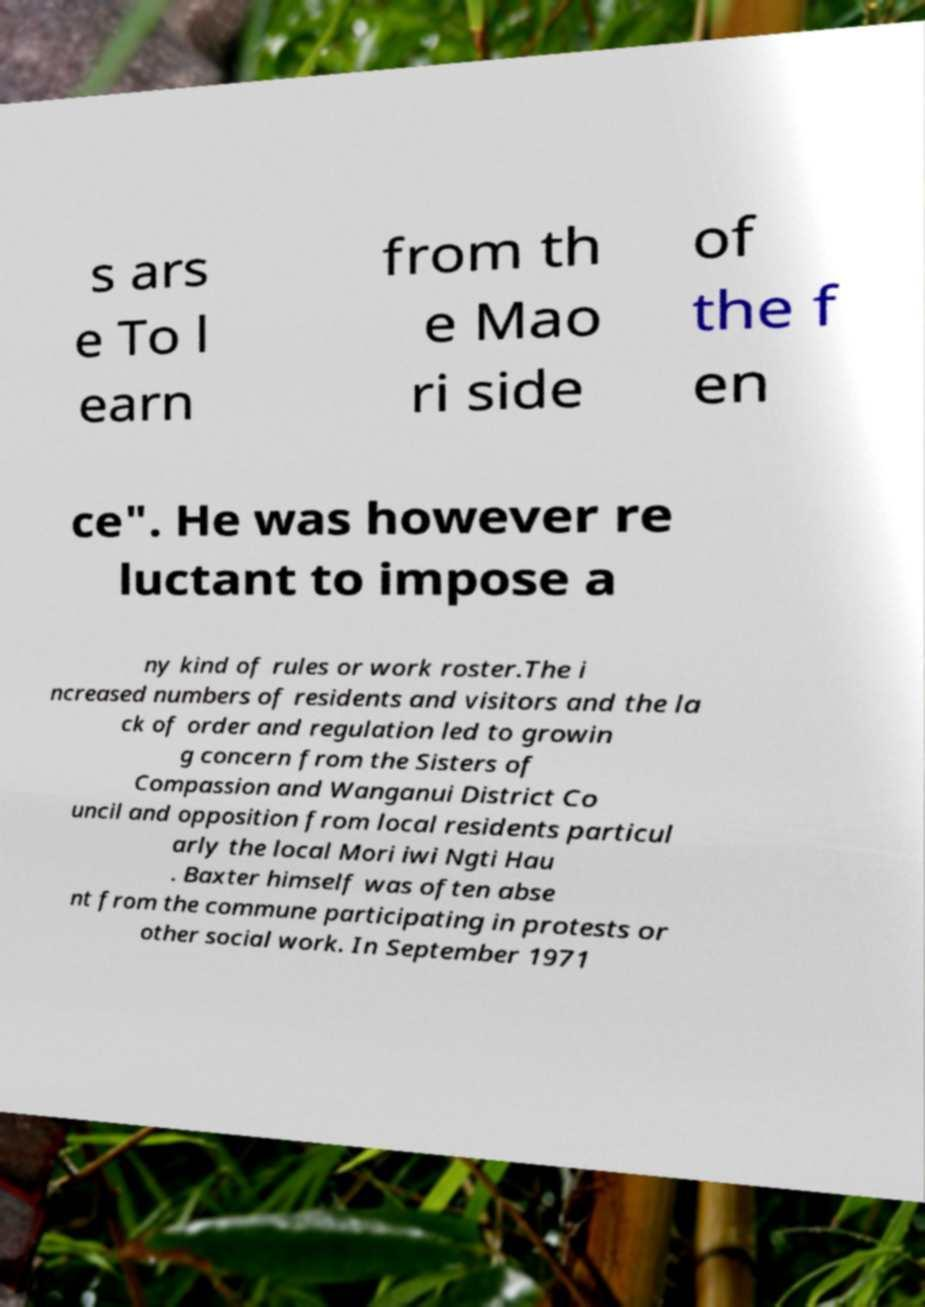What messages or text are displayed in this image? I need them in a readable, typed format. s ars e To l earn from th e Mao ri side of the f en ce". He was however re luctant to impose a ny kind of rules or work roster.The i ncreased numbers of residents and visitors and the la ck of order and regulation led to growin g concern from the Sisters of Compassion and Wanganui District Co uncil and opposition from local residents particul arly the local Mori iwi Ngti Hau . Baxter himself was often abse nt from the commune participating in protests or other social work. In September 1971 